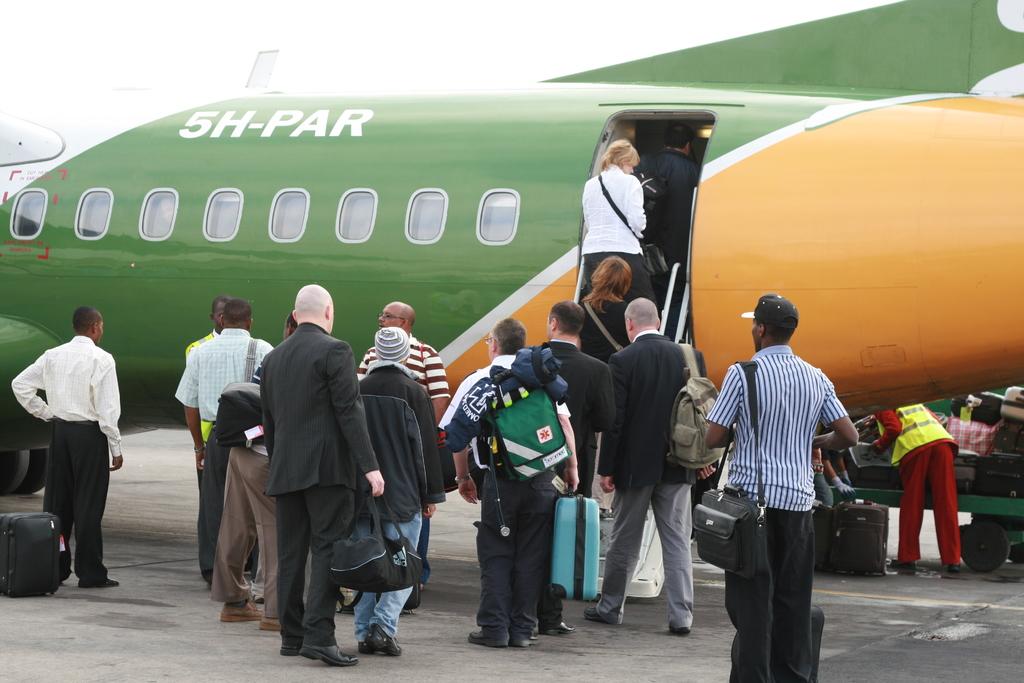What is the id of the plane?
Keep it short and to the point. 5h-par. 